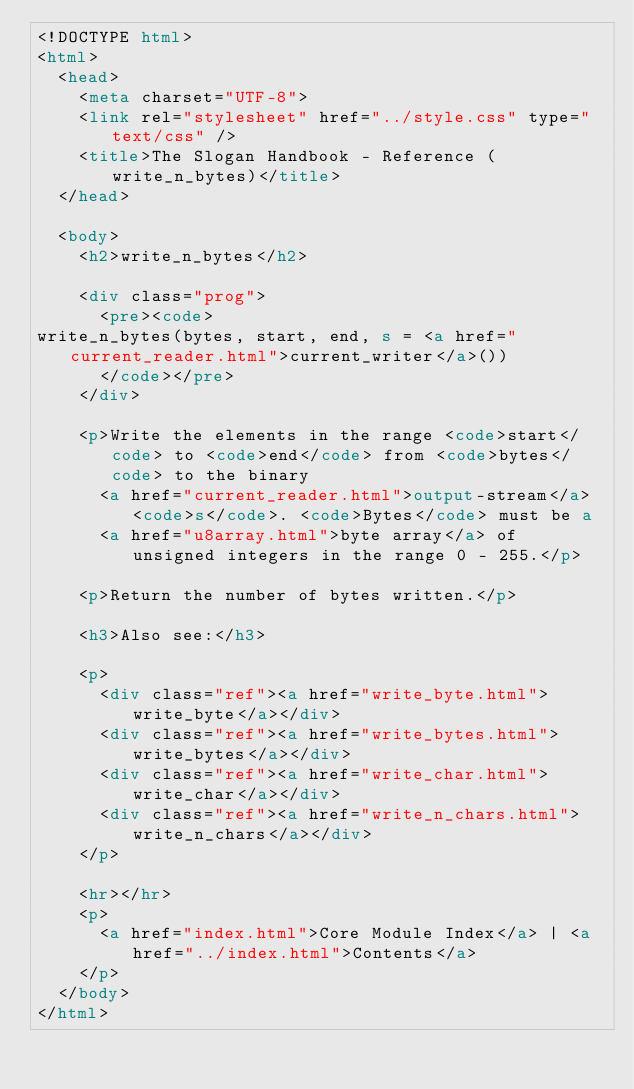<code> <loc_0><loc_0><loc_500><loc_500><_HTML_><!DOCTYPE html>
<html>
  <head>
    <meta charset="UTF-8">
    <link rel="stylesheet" href="../style.css" type="text/css" />
    <title>The Slogan Handbook - Reference (write_n_bytes)</title>
  </head>

  <body>
    <h2>write_n_bytes</h2>

    <div class="prog">
      <pre><code>
write_n_bytes(bytes, start, end, s = <a href="current_reader.html">current_writer</a>())
      </code></pre>
    </div>

    <p>Write the elements in the range <code>start</code> to <code>end</code> from <code>bytes</code> to the binary
      <a href="current_reader.html">output-stream</a> <code>s</code>. <code>Bytes</code> must be a
      <a href="u8array.html">byte array</a> of unsigned integers in the range 0 - 255.</p>

    <p>Return the number of bytes written.</p>
    
    <h3>Also see:</h3>

    <p>
      <div class="ref"><a href="write_byte.html">write_byte</a></div>
      <div class="ref"><a href="write_bytes.html">write_bytes</a></div>      
      <div class="ref"><a href="write_char.html">write_char</a></div>
      <div class="ref"><a href="write_n_chars.html">write_n_chars</a></div>      
    </p>

    <hr></hr>
    <p>
      <a href="index.html">Core Module Index</a> | <a href="../index.html">Contents</a>
    </p>
  </body>
</html>
</code> 